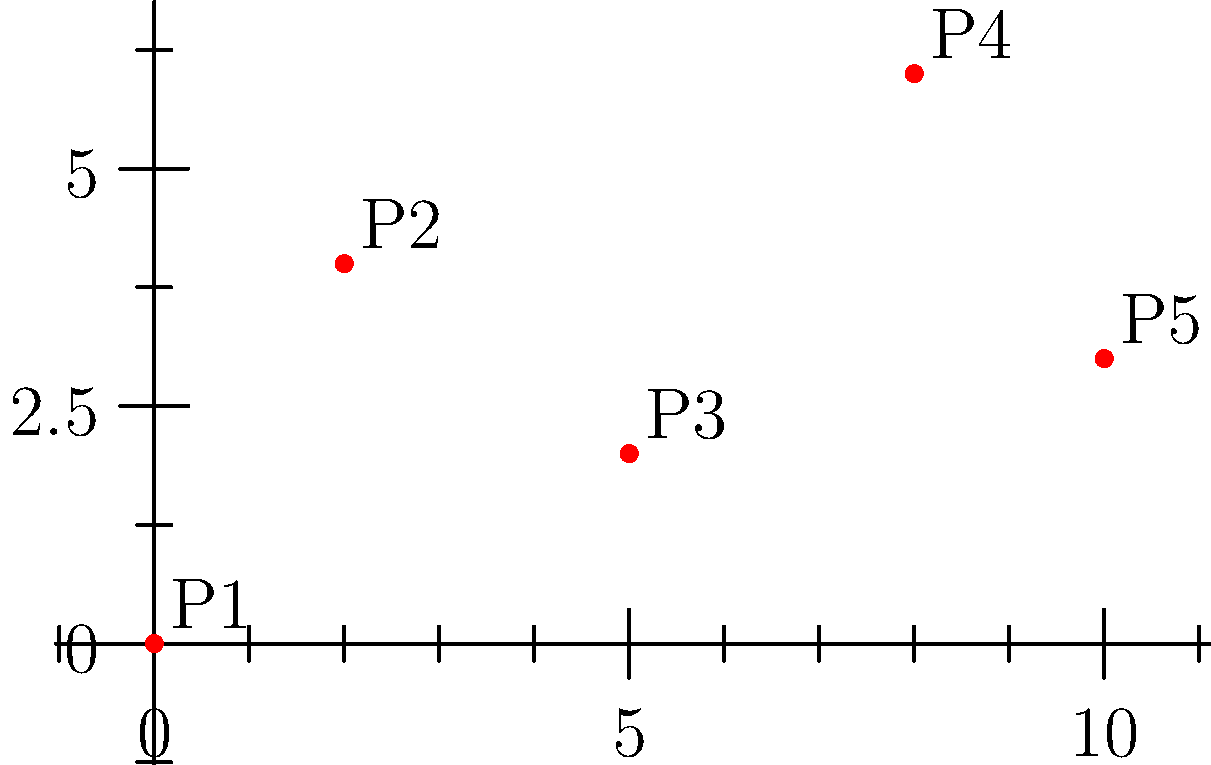In a strategy game, you need to collect resources from multiple points on the map. Given the coordinates of 5 resource points (P1 to P5) on a Cartesian plane, calculate the minimum distance required to visit all points and return to the starting point (P1). Assume you can move freely in any direction. To find the shortest path, we need to calculate the distances between all points and find the optimal route. This is known as the Traveling Salesman Problem.

Step 1: Calculate distances between all points using the distance formula:
$d = \sqrt{(x_2-x_1)^2 + (y_2-y_1)^2}$

Step 2: Create a distance matrix:
$$
\begin{matrix}
P1 & P2 & P3 & P4 & P5 \\
0 & 4.47 & 5.39 & 10.00 & 10.44 \\
4.47 & 0 & 3.61 & 6.32 & 8.06 \\
5.39 & 3.61 & 0 & 3.61 & 5.00 \\
10.00 & 6.32 & 3.61 & 0 & 2.24 \\
10.44 & 8.06 & 5.00 & 2.24 & 0
\end{matrix}
$$

Step 3: Find the shortest path using a heuristic approach (nearest neighbor):
P1 → P2 (4.47)
P2 → P3 (3.61)
P3 → P4 (3.61)
P4 → P5 (2.24)
P5 → P1 (10.44)

Step 4: Calculate total distance:
Total distance = 4.47 + 3.61 + 3.61 + 2.24 + 10.44 = 24.37

Note: This may not be the absolute optimal solution, but it's a good approximation for gameplay purposes.
Answer: 24.37 units 